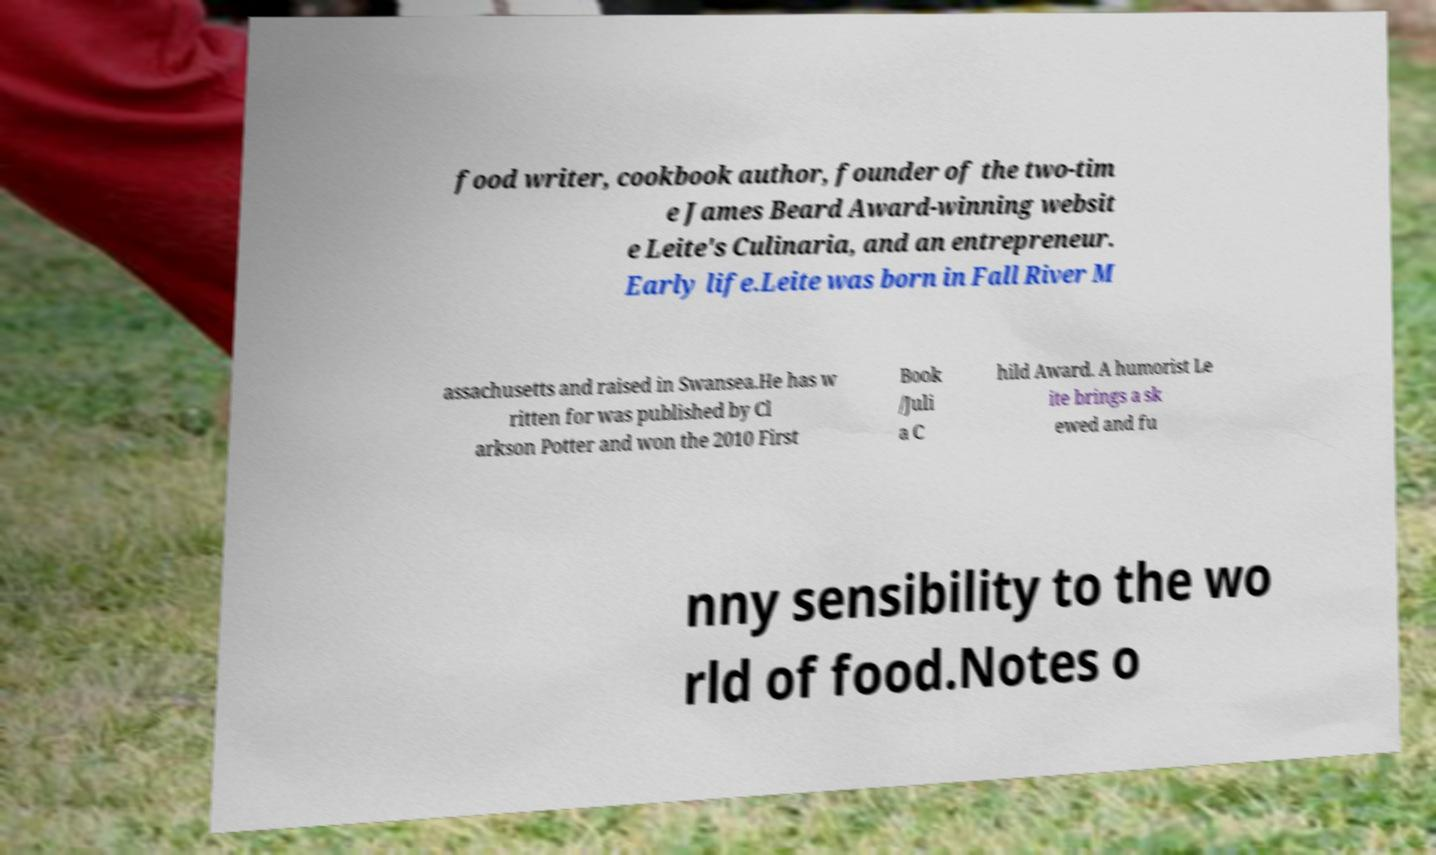Could you assist in decoding the text presented in this image and type it out clearly? food writer, cookbook author, founder of the two-tim e James Beard Award-winning websit e Leite's Culinaria, and an entrepreneur. Early life.Leite was born in Fall River M assachusetts and raised in Swansea.He has w ritten for was published by Cl arkson Potter and won the 2010 First Book /Juli a C hild Award. A humorist Le ite brings a sk ewed and fu nny sensibility to the wo rld of food.Notes o 